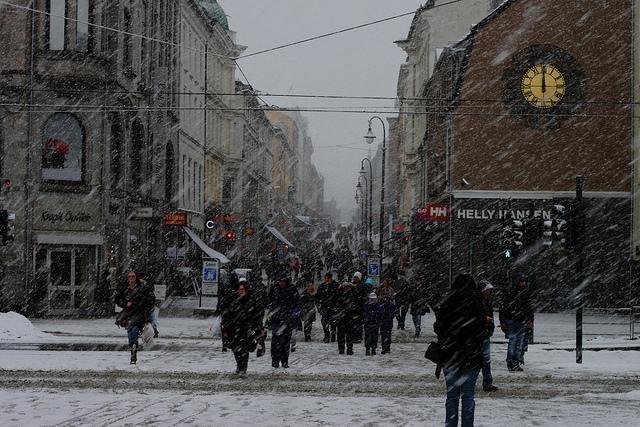How many people can you see?
Give a very brief answer. 4. How many dogs are to the right of the person?
Give a very brief answer. 0. 